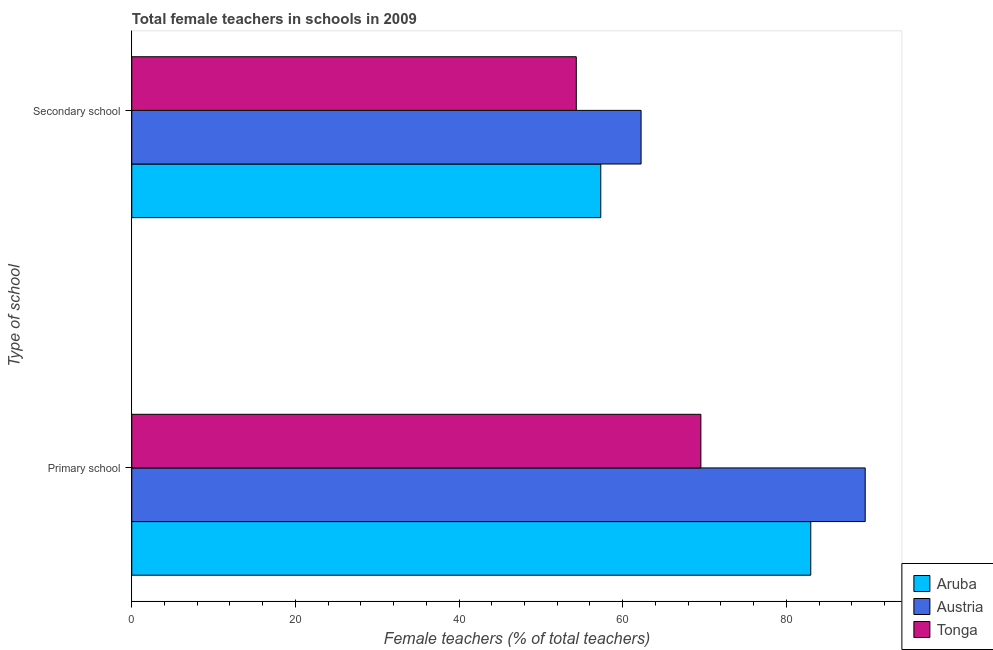Are the number of bars on each tick of the Y-axis equal?
Provide a short and direct response. Yes. How many bars are there on the 1st tick from the bottom?
Offer a terse response. 3. What is the label of the 2nd group of bars from the top?
Give a very brief answer. Primary school. What is the percentage of female teachers in secondary schools in Aruba?
Provide a short and direct response. 57.32. Across all countries, what is the maximum percentage of female teachers in secondary schools?
Make the answer very short. 62.25. Across all countries, what is the minimum percentage of female teachers in secondary schools?
Make the answer very short. 54.33. In which country was the percentage of female teachers in primary schools maximum?
Ensure brevity in your answer.  Austria. In which country was the percentage of female teachers in primary schools minimum?
Your answer should be compact. Tonga. What is the total percentage of female teachers in primary schools in the graph?
Give a very brief answer. 242.19. What is the difference between the percentage of female teachers in secondary schools in Austria and that in Aruba?
Provide a succinct answer. 4.93. What is the difference between the percentage of female teachers in primary schools in Tonga and the percentage of female teachers in secondary schools in Aruba?
Make the answer very short. 12.24. What is the average percentage of female teachers in primary schools per country?
Provide a short and direct response. 80.73. What is the difference between the percentage of female teachers in secondary schools and percentage of female teachers in primary schools in Tonga?
Your answer should be compact. -15.23. What is the ratio of the percentage of female teachers in primary schools in Austria to that in Aruba?
Provide a short and direct response. 1.08. Is the percentage of female teachers in primary schools in Tonga less than that in Austria?
Make the answer very short. Yes. What does the 2nd bar from the bottom in Primary school represents?
Your answer should be compact. Austria. How many bars are there?
Give a very brief answer. 6. Are all the bars in the graph horizontal?
Provide a short and direct response. Yes. How many countries are there in the graph?
Provide a short and direct response. 3. Where does the legend appear in the graph?
Keep it short and to the point. Bottom right. How are the legend labels stacked?
Your response must be concise. Vertical. What is the title of the graph?
Provide a short and direct response. Total female teachers in schools in 2009. What is the label or title of the X-axis?
Provide a succinct answer. Female teachers (% of total teachers). What is the label or title of the Y-axis?
Keep it short and to the point. Type of school. What is the Female teachers (% of total teachers) of Aruba in Primary school?
Make the answer very short. 82.99. What is the Female teachers (% of total teachers) of Austria in Primary school?
Offer a terse response. 89.64. What is the Female teachers (% of total teachers) in Tonga in Primary school?
Offer a very short reply. 69.56. What is the Female teachers (% of total teachers) in Aruba in Secondary school?
Ensure brevity in your answer.  57.32. What is the Female teachers (% of total teachers) of Austria in Secondary school?
Keep it short and to the point. 62.25. What is the Female teachers (% of total teachers) in Tonga in Secondary school?
Offer a very short reply. 54.33. Across all Type of school, what is the maximum Female teachers (% of total teachers) of Aruba?
Give a very brief answer. 82.99. Across all Type of school, what is the maximum Female teachers (% of total teachers) in Austria?
Make the answer very short. 89.64. Across all Type of school, what is the maximum Female teachers (% of total teachers) in Tonga?
Offer a terse response. 69.56. Across all Type of school, what is the minimum Female teachers (% of total teachers) in Aruba?
Provide a short and direct response. 57.32. Across all Type of school, what is the minimum Female teachers (% of total teachers) in Austria?
Offer a terse response. 62.25. Across all Type of school, what is the minimum Female teachers (% of total teachers) of Tonga?
Your answer should be very brief. 54.33. What is the total Female teachers (% of total teachers) in Aruba in the graph?
Keep it short and to the point. 140.31. What is the total Female teachers (% of total teachers) in Austria in the graph?
Ensure brevity in your answer.  151.89. What is the total Female teachers (% of total teachers) in Tonga in the graph?
Ensure brevity in your answer.  123.89. What is the difference between the Female teachers (% of total teachers) in Aruba in Primary school and that in Secondary school?
Give a very brief answer. 25.67. What is the difference between the Female teachers (% of total teachers) of Austria in Primary school and that in Secondary school?
Offer a very short reply. 27.39. What is the difference between the Female teachers (% of total teachers) of Tonga in Primary school and that in Secondary school?
Your answer should be very brief. 15.23. What is the difference between the Female teachers (% of total teachers) of Aruba in Primary school and the Female teachers (% of total teachers) of Austria in Secondary school?
Your answer should be compact. 20.74. What is the difference between the Female teachers (% of total teachers) of Aruba in Primary school and the Female teachers (% of total teachers) of Tonga in Secondary school?
Your answer should be very brief. 28.66. What is the difference between the Female teachers (% of total teachers) in Austria in Primary school and the Female teachers (% of total teachers) in Tonga in Secondary school?
Provide a short and direct response. 35.31. What is the average Female teachers (% of total teachers) in Aruba per Type of school?
Your answer should be compact. 70.16. What is the average Female teachers (% of total teachers) in Austria per Type of school?
Ensure brevity in your answer.  75.95. What is the average Female teachers (% of total teachers) in Tonga per Type of school?
Offer a terse response. 61.95. What is the difference between the Female teachers (% of total teachers) of Aruba and Female teachers (% of total teachers) of Austria in Primary school?
Offer a very short reply. -6.65. What is the difference between the Female teachers (% of total teachers) in Aruba and Female teachers (% of total teachers) in Tonga in Primary school?
Your answer should be compact. 13.43. What is the difference between the Female teachers (% of total teachers) of Austria and Female teachers (% of total teachers) of Tonga in Primary school?
Keep it short and to the point. 20.08. What is the difference between the Female teachers (% of total teachers) of Aruba and Female teachers (% of total teachers) of Austria in Secondary school?
Provide a short and direct response. -4.93. What is the difference between the Female teachers (% of total teachers) in Aruba and Female teachers (% of total teachers) in Tonga in Secondary school?
Give a very brief answer. 2.99. What is the difference between the Female teachers (% of total teachers) in Austria and Female teachers (% of total teachers) in Tonga in Secondary school?
Offer a terse response. 7.92. What is the ratio of the Female teachers (% of total teachers) in Aruba in Primary school to that in Secondary school?
Offer a very short reply. 1.45. What is the ratio of the Female teachers (% of total teachers) of Austria in Primary school to that in Secondary school?
Ensure brevity in your answer.  1.44. What is the ratio of the Female teachers (% of total teachers) in Tonga in Primary school to that in Secondary school?
Give a very brief answer. 1.28. What is the difference between the highest and the second highest Female teachers (% of total teachers) in Aruba?
Keep it short and to the point. 25.67. What is the difference between the highest and the second highest Female teachers (% of total teachers) of Austria?
Offer a very short reply. 27.39. What is the difference between the highest and the second highest Female teachers (% of total teachers) in Tonga?
Keep it short and to the point. 15.23. What is the difference between the highest and the lowest Female teachers (% of total teachers) in Aruba?
Provide a succinct answer. 25.67. What is the difference between the highest and the lowest Female teachers (% of total teachers) of Austria?
Offer a terse response. 27.39. What is the difference between the highest and the lowest Female teachers (% of total teachers) in Tonga?
Your answer should be very brief. 15.23. 